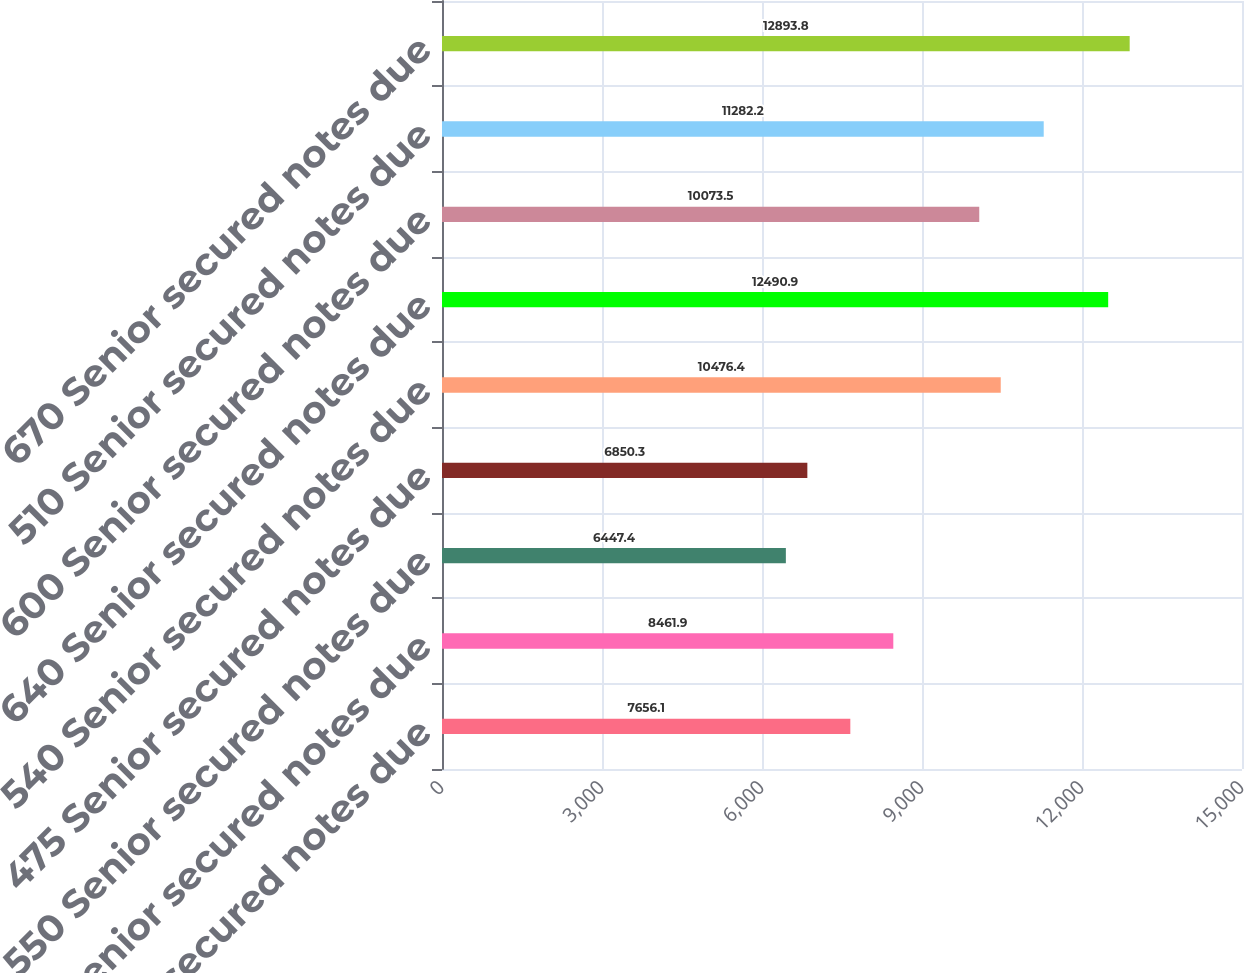Convert chart. <chart><loc_0><loc_0><loc_500><loc_500><bar_chart><fcel>525 Senior secured notes due<fcel>465 Senior secured notes due<fcel>550 Senior secured notes due<fcel>475 Senior secured notes due<fcel>540 Senior secured notes due<fcel>640 Senior secured notes due<fcel>600 Senior secured notes due<fcel>510 Senior secured notes due<fcel>670 Senior secured notes due<nl><fcel>7656.1<fcel>8461.9<fcel>6447.4<fcel>6850.3<fcel>10476.4<fcel>12490.9<fcel>10073.5<fcel>11282.2<fcel>12893.8<nl></chart> 